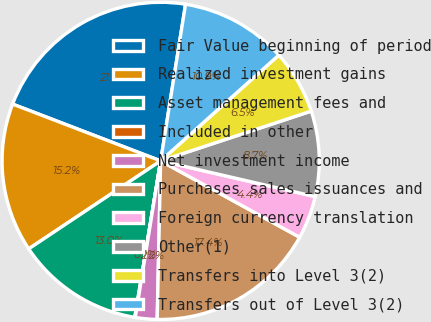<chart> <loc_0><loc_0><loc_500><loc_500><pie_chart><fcel>Fair Value beginning of period<fcel>Realized investment gains<fcel>Asset management fees and<fcel>Included in other<fcel>Net investment income<fcel>Purchases sales issuances and<fcel>Foreign currency translation<fcel>Other(1)<fcel>Transfers into Level 3(2)<fcel>Transfers out of Level 3(2)<nl><fcel>21.68%<fcel>15.19%<fcel>13.03%<fcel>0.05%<fcel>2.21%<fcel>17.35%<fcel>4.38%<fcel>8.7%<fcel>6.54%<fcel>10.87%<nl></chart> 